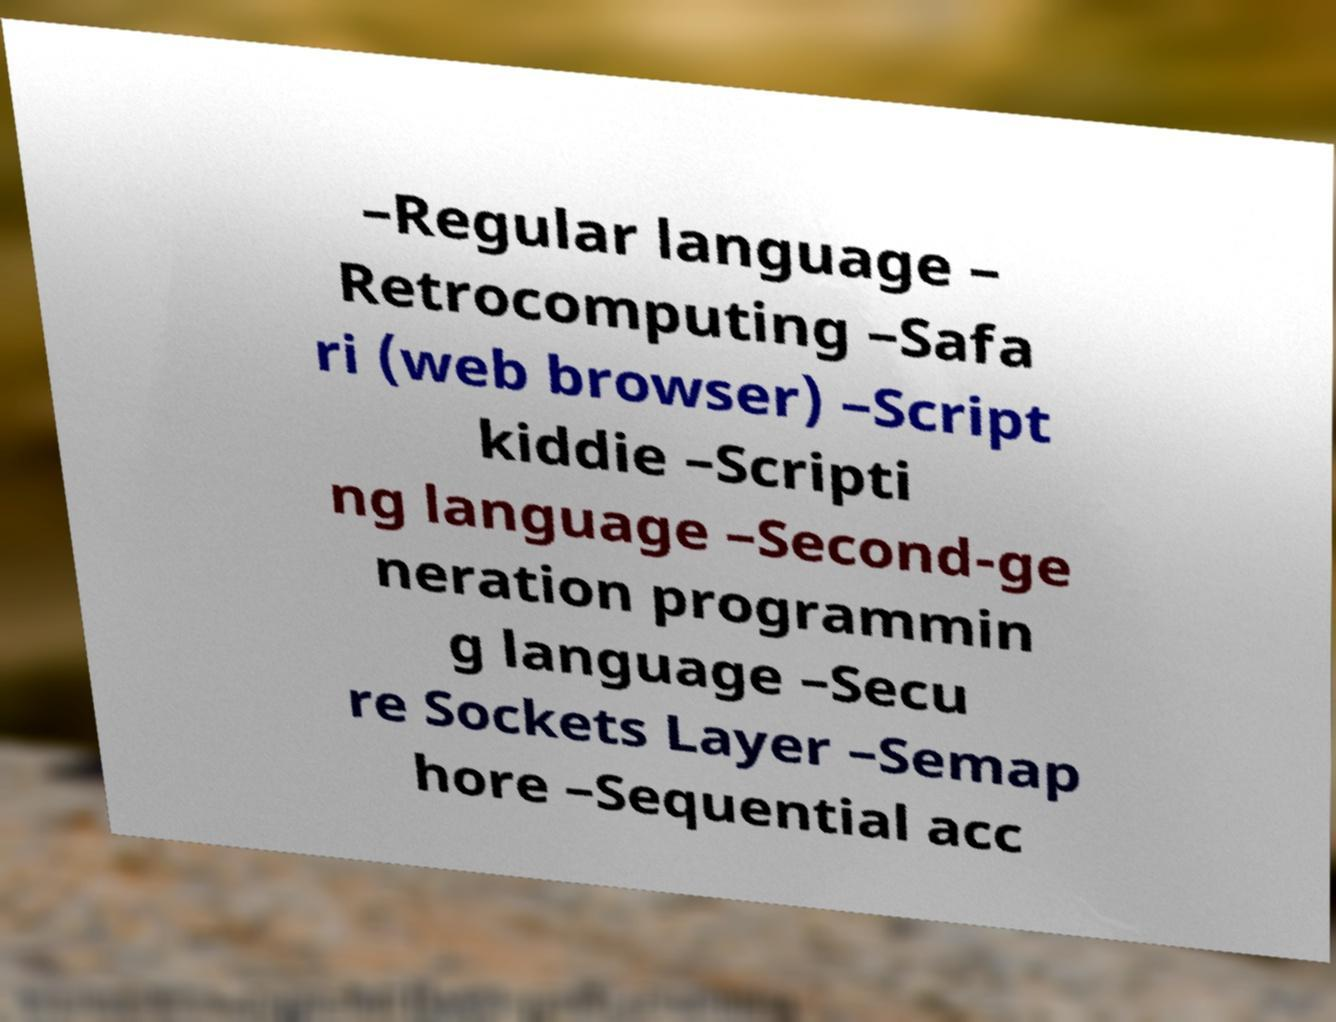I need the written content from this picture converted into text. Can you do that? –Regular language – Retrocomputing –Safa ri (web browser) –Script kiddie –Scripti ng language –Second-ge neration programmin g language –Secu re Sockets Layer –Semap hore –Sequential acc 